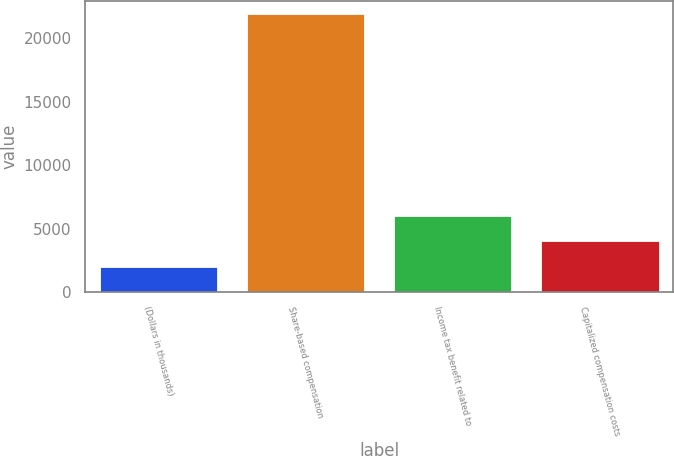Convert chart to OTSL. <chart><loc_0><loc_0><loc_500><loc_500><bar_chart><fcel>(Dollars in thousands)<fcel>Share-based compensation<fcel>Income tax benefit related to<fcel>Capitalized compensation costs<nl><fcel>2012<fcel>21861<fcel>6011<fcel>3996.9<nl></chart> 